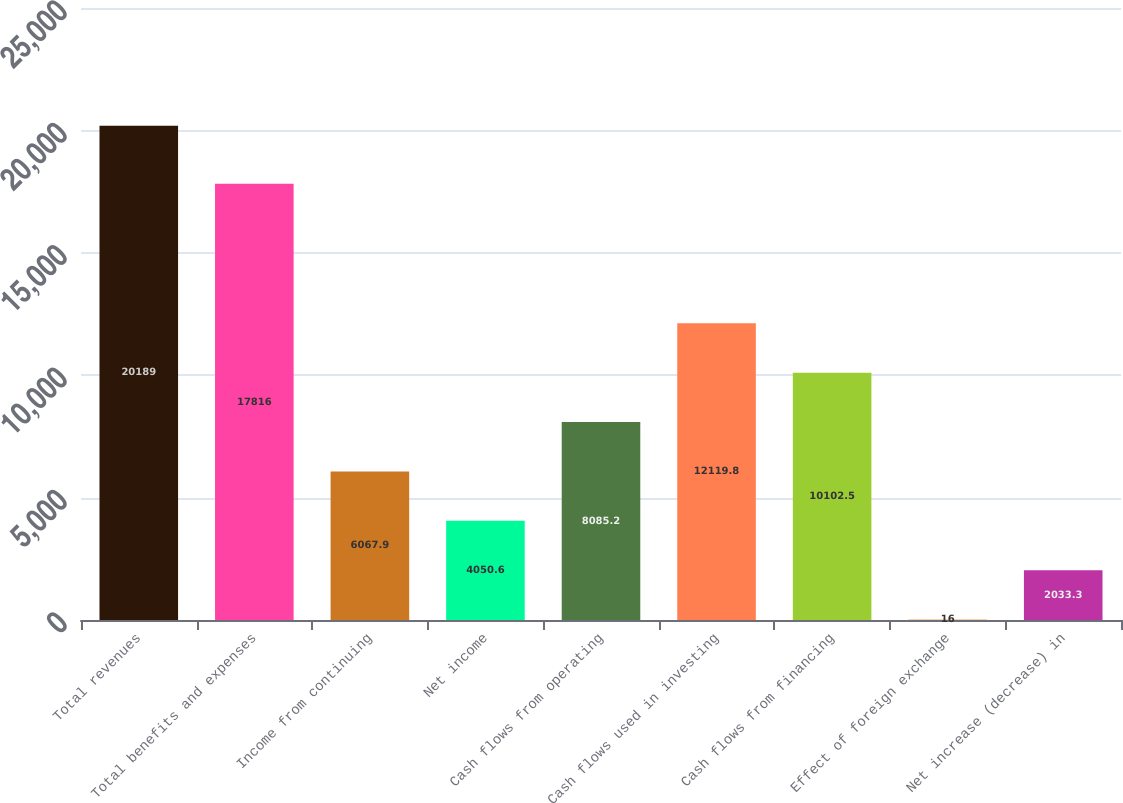<chart> <loc_0><loc_0><loc_500><loc_500><bar_chart><fcel>Total revenues<fcel>Total benefits and expenses<fcel>Income from continuing<fcel>Net income<fcel>Cash flows from operating<fcel>Cash flows used in investing<fcel>Cash flows from financing<fcel>Effect of foreign exchange<fcel>Net increase (decrease) in<nl><fcel>20189<fcel>17816<fcel>6067.9<fcel>4050.6<fcel>8085.2<fcel>12119.8<fcel>10102.5<fcel>16<fcel>2033.3<nl></chart> 